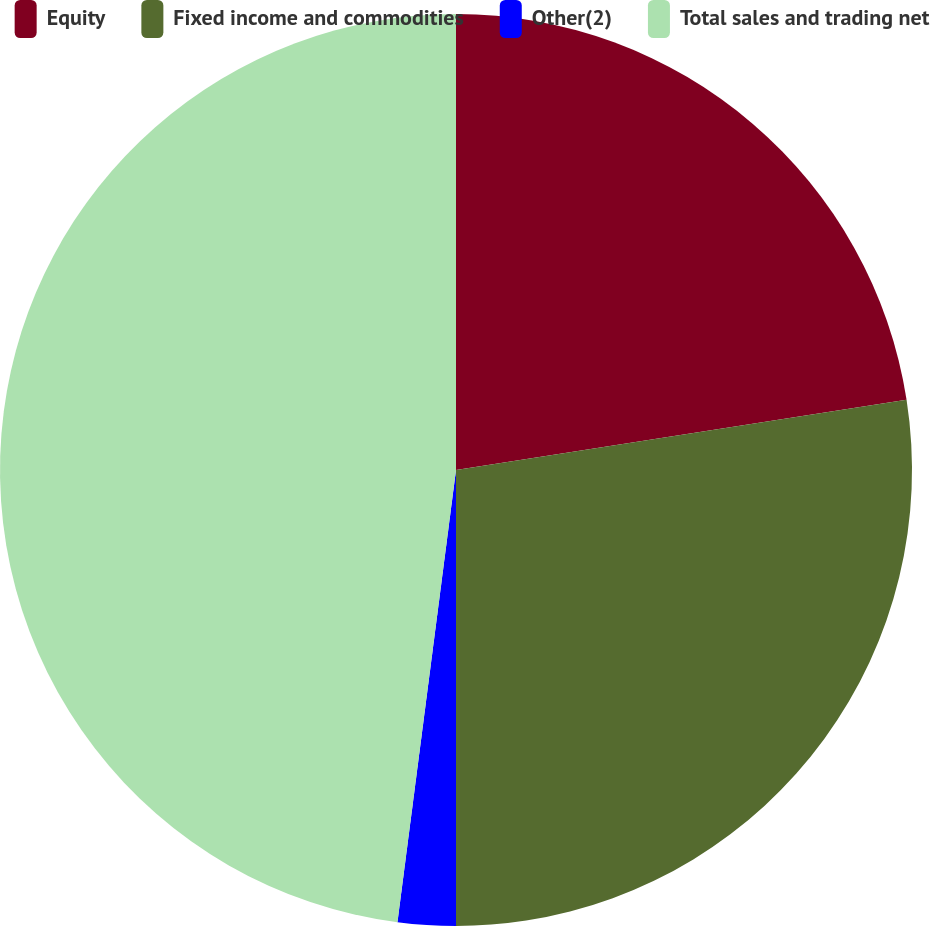<chart> <loc_0><loc_0><loc_500><loc_500><pie_chart><fcel>Equity<fcel>Fixed income and commodities<fcel>Other(2)<fcel>Total sales and trading net<nl><fcel>22.54%<fcel>27.46%<fcel>2.05%<fcel>47.95%<nl></chart> 